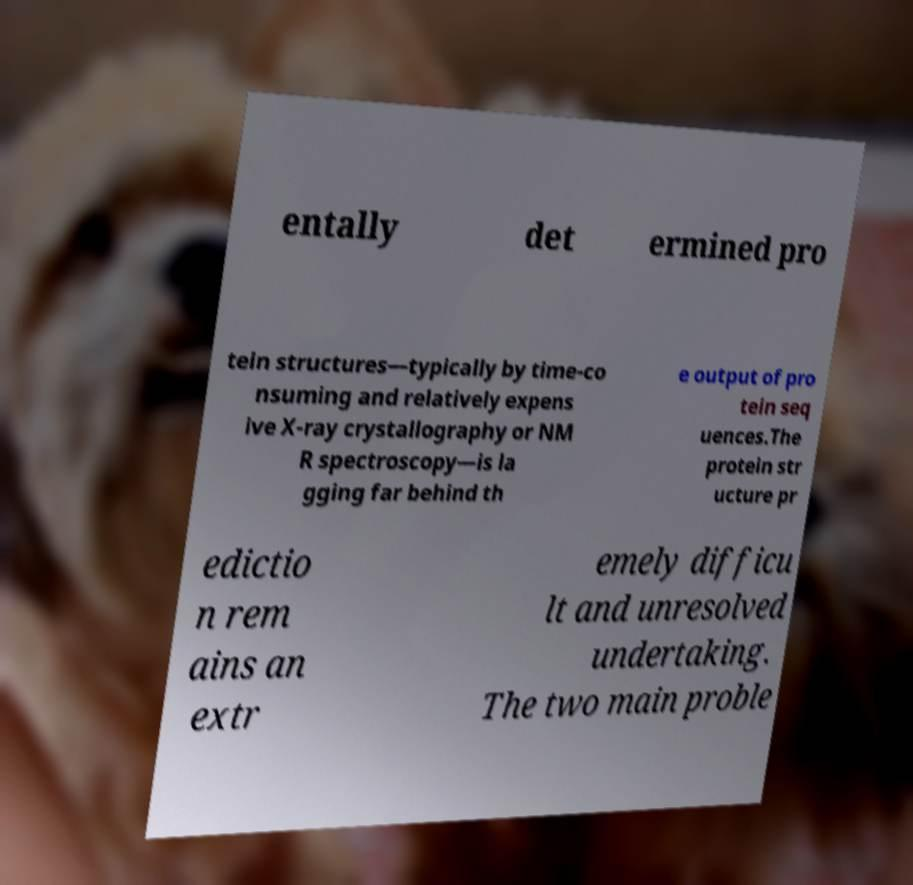Could you assist in decoding the text presented in this image and type it out clearly? entally det ermined pro tein structures—typically by time-co nsuming and relatively expens ive X-ray crystallography or NM R spectroscopy—is la gging far behind th e output of pro tein seq uences.The protein str ucture pr edictio n rem ains an extr emely difficu lt and unresolved undertaking. The two main proble 